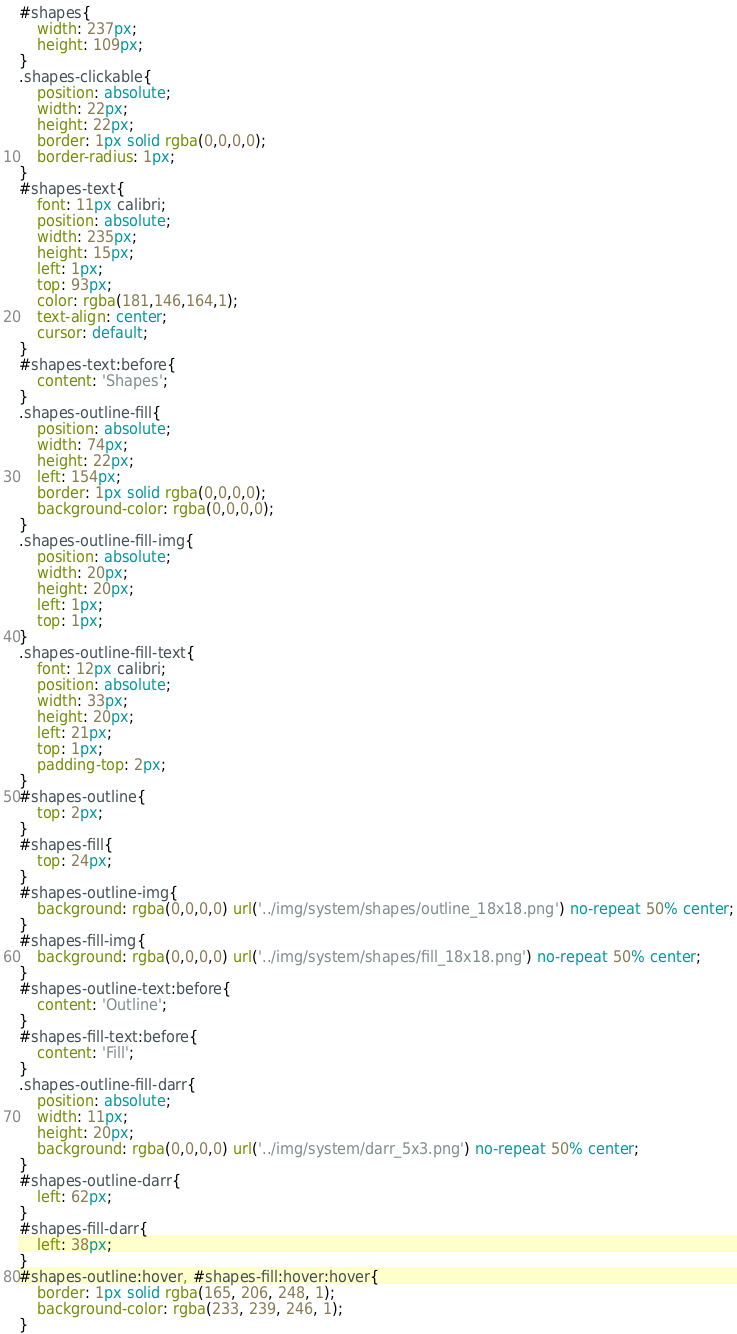<code> <loc_0><loc_0><loc_500><loc_500><_CSS_>#shapes{
	width: 237px;
	height: 109px;
}
.shapes-clickable{
	position: absolute;
	width: 22px;
	height: 22px;
	border: 1px solid rgba(0,0,0,0);
	border-radius: 1px;
}
#shapes-text{
	font: 11px calibri;
	position: absolute;
	width: 235px;
	height: 15px;
	left: 1px;
	top: 93px;
	color: rgba(181,146,164,1);
	text-align: center;
	cursor: default;
}
#shapes-text:before{
	content: 'Shapes';
}
.shapes-outline-fill{
	position: absolute;
	width: 74px;
	height: 22px;
	left: 154px;
	border: 1px solid rgba(0,0,0,0);
	background-color: rgba(0,0,0,0);
}
.shapes-outline-fill-img{
	position: absolute;
	width: 20px;
	height: 20px;
	left: 1px;
	top: 1px;
}
.shapes-outline-fill-text{
	font: 12px calibri;
	position: absolute;
	width: 33px;
	height: 20px;
	left: 21px;
	top: 1px;
	padding-top: 2px;	
}
#shapes-outline{
	top: 2px;
}
#shapes-fill{
	top: 24px;
}
#shapes-outline-img{
	background: rgba(0,0,0,0) url('../img/system/shapes/outline_18x18.png') no-repeat 50% center;
}
#shapes-fill-img{
	background: rgba(0,0,0,0) url('../img/system/shapes/fill_18x18.png') no-repeat 50% center;
}
#shapes-outline-text:before{
	content: 'Outline';
}
#shapes-fill-text:before{
	content: 'Fill';
}
.shapes-outline-fill-darr{
	position: absolute;
	width: 11px;
	height: 20px;
	background: rgba(0,0,0,0) url('../img/system/darr_5x3.png') no-repeat 50% center;	
}
#shapes-outline-darr{
	left: 62px;
}
#shapes-fill-darr{
	left: 38px;
}
#shapes-outline:hover, #shapes-fill:hover:hover{
	border: 1px solid rgba(165, 206, 248, 1);
	background-color: rgba(233, 239, 246, 1);
}</code> 